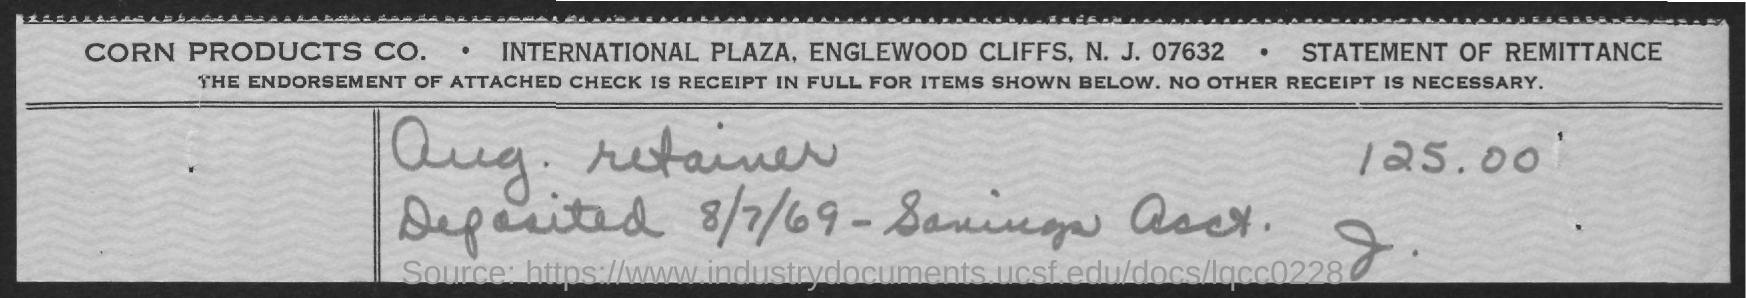Outline some significant characteristics in this image. On August 7th, 1969, the deposited date was. The amount mentioned is 125.00. 